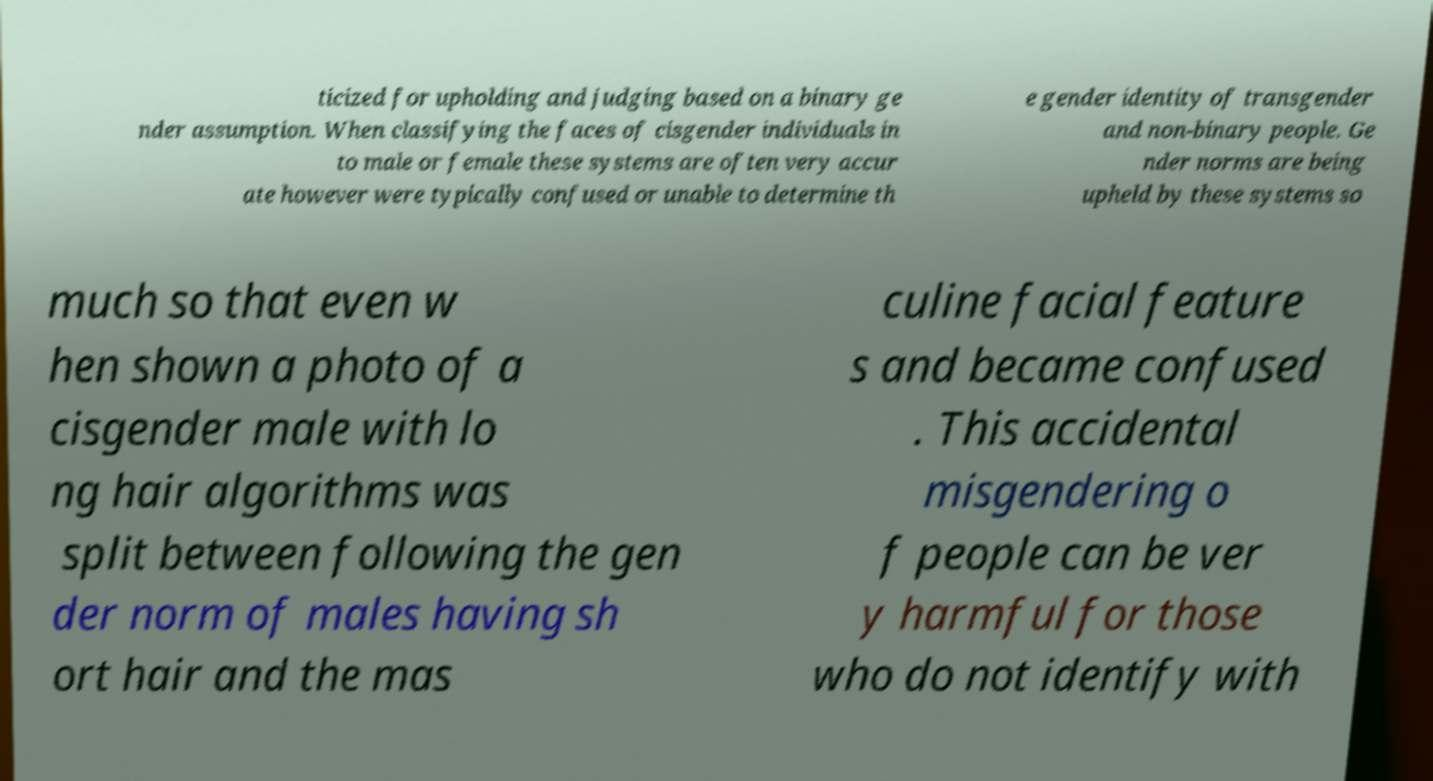What messages or text are displayed in this image? I need them in a readable, typed format. ticized for upholding and judging based on a binary ge nder assumption. When classifying the faces of cisgender individuals in to male or female these systems are often very accur ate however were typically confused or unable to determine th e gender identity of transgender and non-binary people. Ge nder norms are being upheld by these systems so much so that even w hen shown a photo of a cisgender male with lo ng hair algorithms was split between following the gen der norm of males having sh ort hair and the mas culine facial feature s and became confused . This accidental misgendering o f people can be ver y harmful for those who do not identify with 